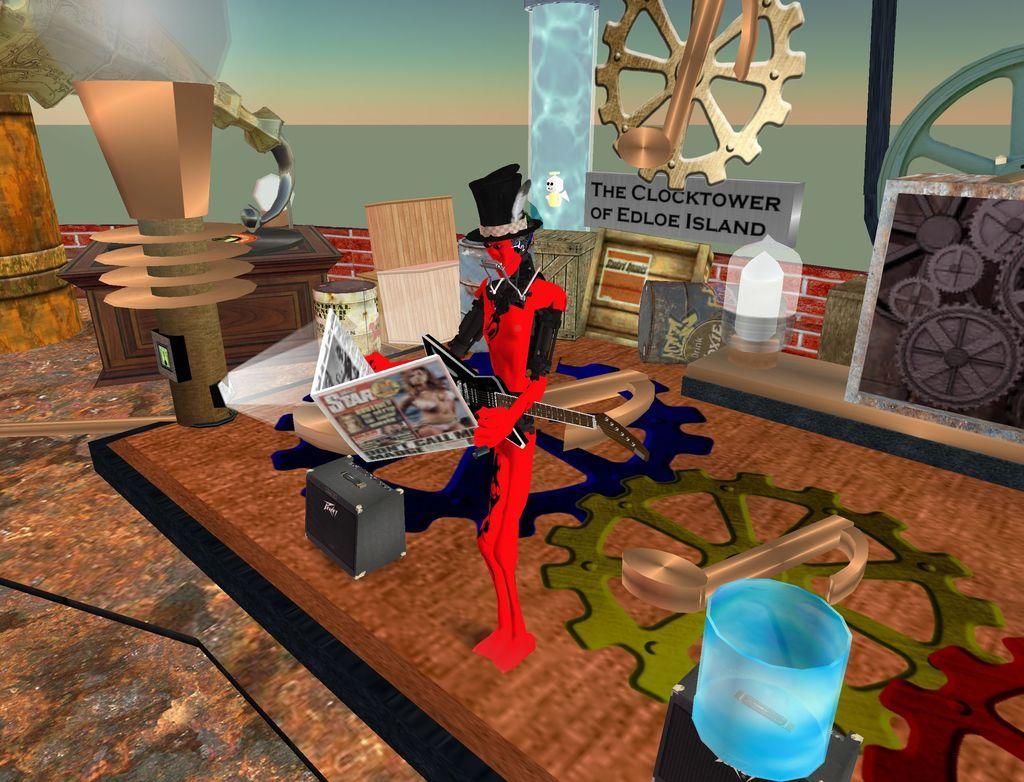Describe this image in one or two sentences. It is a graphical image. In the center of the image we can see a person is standing and he is holding a newspaper. At the bottom of the image, we can see some objects. In the background there is a table, board with some text and a few other objects. 